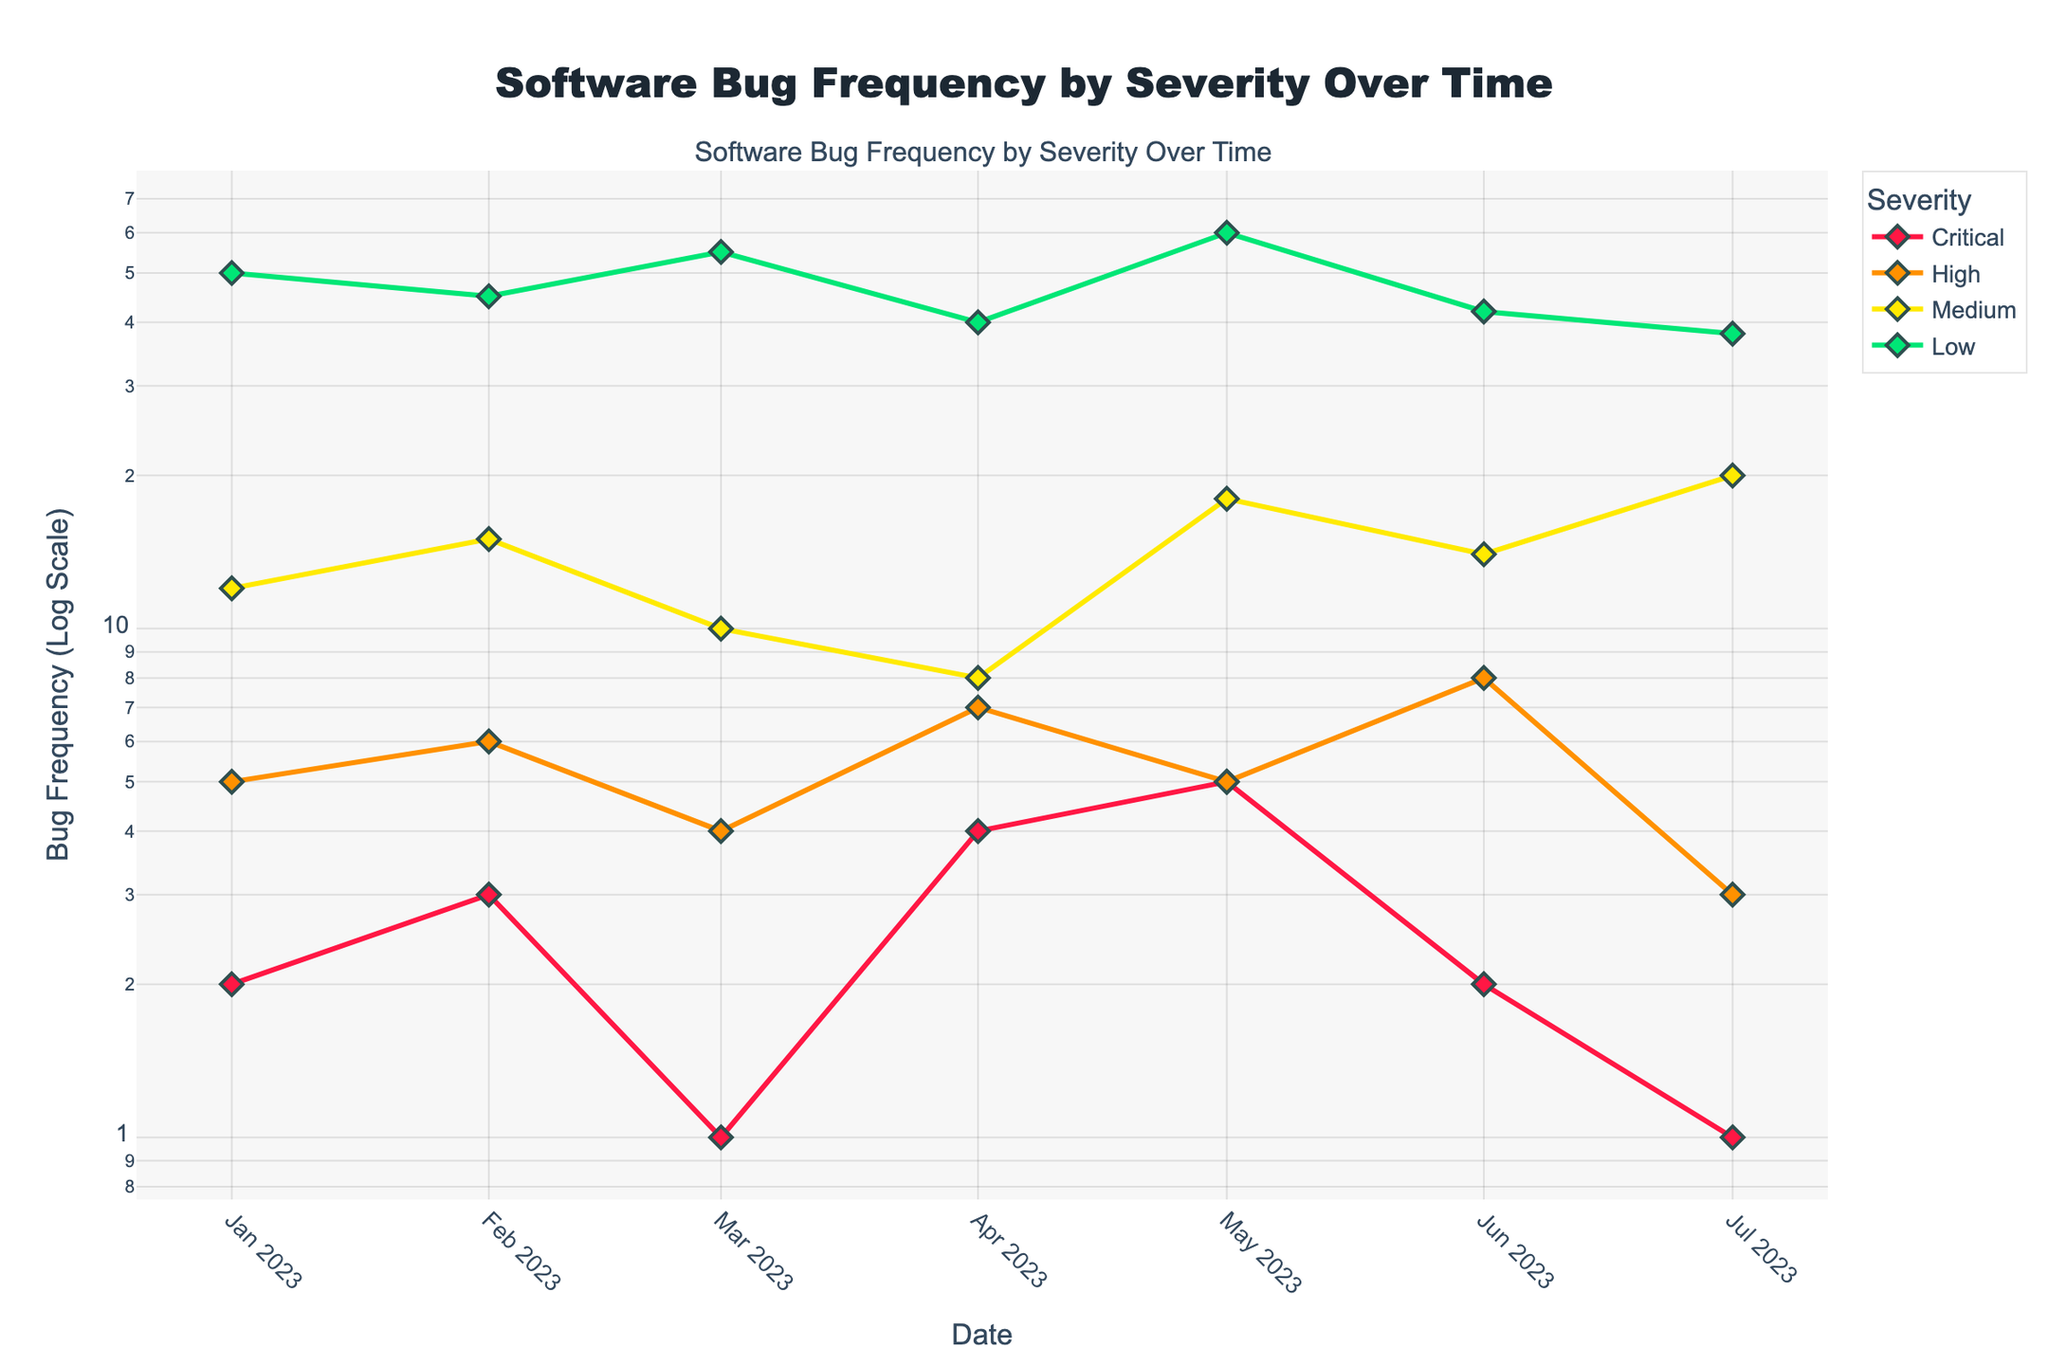What is the title of the plot? The title of the plot is usually located at the top center of the figure and provides a brief description of what the plot represents. In this case, it reads "Software Bug Frequency by Severity Over Time"
Answer: Software Bug Frequency by Severity Over Time Which severity level had the highest bug frequency in July 2023? Look for the data points corresponding to July 2023 and compare the frequencies of each severity level. The highest bug frequency for that month is for the "medium" severity.
Answer: Medium How does the frequency of critical bugs change from January 2023 to July 2023? Trace the line for the "critical" severity level from January to July. The frequencies are as follows: January (2), February (3), March (1), April (4), May (5), June (2), July (1). There is some fluctuation, increasing in April and May, but decreases overall from 2 to 1.
Answer: Decreases Compare the bug frequency trend for high and low severity levels. Which one shows more variation? Look at the lines for "high" and "low" severities. The high severity line fluctuates between 3 and 8, while the low severity line ranges between 38 and 60. The low severity shows more variation with wider fluctuations.
Answer: Low What is the bug frequency for medium severity in May 2023? Follow the "medium" severity line to the data point corresponding to May 2023. The frequency is 18.
Answer: 18 Are there any months where the number of critical bugs is equal to the number of high severity bugs? Compare the data points for "critical" and "high" severity levels in each month. Both are equal at 5 in May 2023.
Answer: May 2023 What can be deduced from the logarithmic scale in the plot regarding small vs large values? A logarithmic scale helps in visualizing both small and large values effectively. In this plot, it shows how even small values, like critical bugs, are distinguishable and how large values, like low severity bugs, can be compared despite the wide range.
Answer: Enhances visibility of both small and large values What was the overall trend for medium severity bugs from January to July 2023? Follow the line for medium severity from January to July, observing the values: January (12), February (15), March (10), April (8), May (18), June (14), July (20). There is an overall increasing trend despite some fluctuations.
Answer: Increasing For which severity level is the color green used? Identify the color used for each severity level by tracing the lines: green corresponds to the "low" severity level.
Answer: Low How did the frequency of high severity bugs in June 2023 compare to that in April 2023? Trace the "high" severity line to find the values for April (7) and June (8). Comparing the two, June has a slightly higher frequency.
Answer: Higher in June 